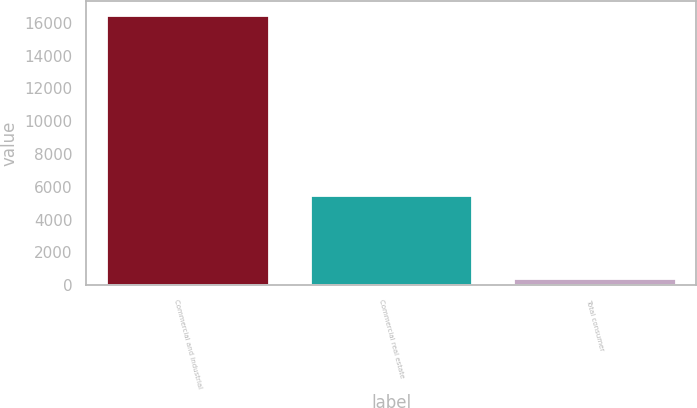Convert chart to OTSL. <chart><loc_0><loc_0><loc_500><loc_500><bar_chart><fcel>Commercial and industrial<fcel>Commercial real estate<fcel>Total consumer<nl><fcel>16507<fcel>5473<fcel>431<nl></chart> 